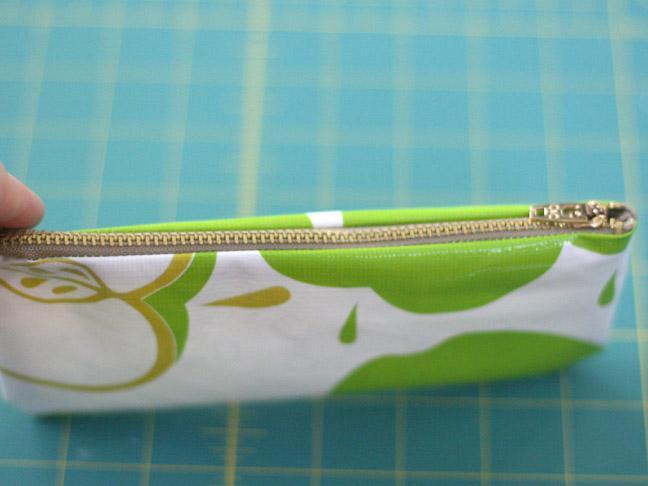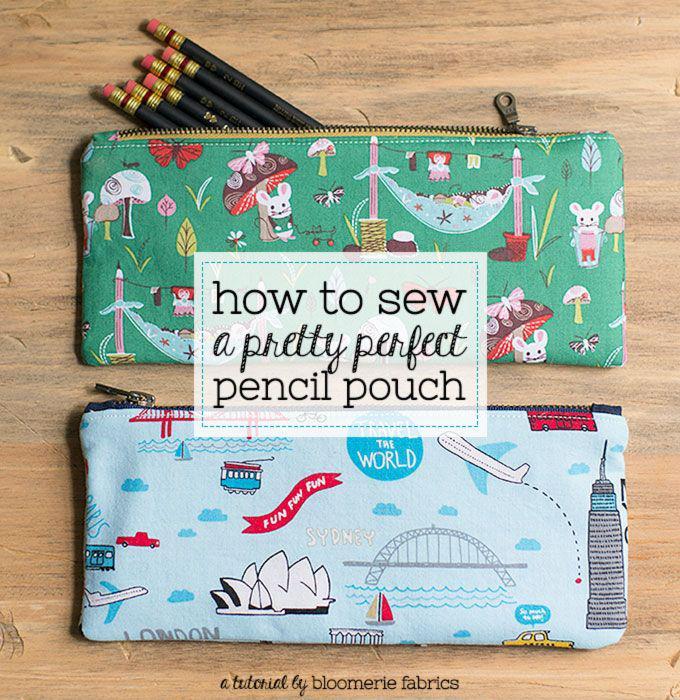The first image is the image on the left, the second image is the image on the right. Considering the images on both sides, is "There are at least 3 zipper pouches in the right image." valid? Answer yes or no. No. 